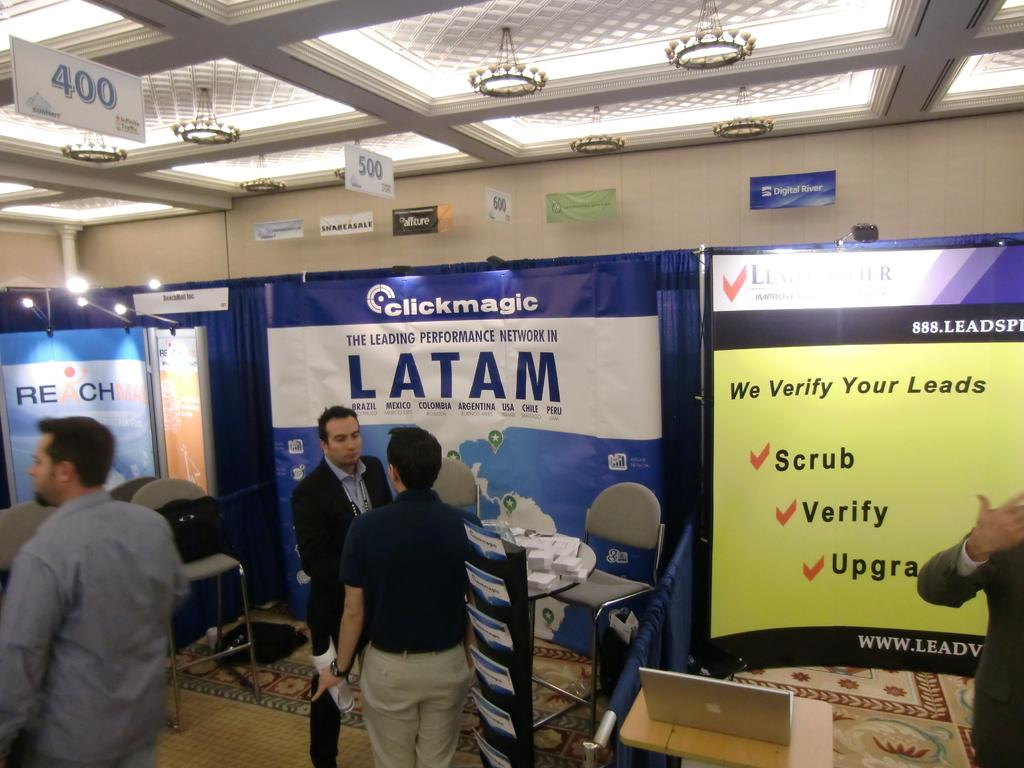What can be seen in the image involving people? There are people standing in the image. What type of furniture is present in the image? Chairs are present in the image. What electronic device can be seen on a table in the image? There is a laptop on a table in the image. What can be seen in the background of the image? Banners are visible in the background of the image. Where is the nest located in the image? There is no nest present in the image. What type of guide can be seen assisting the people in the image? There is no guide present in the image; the people are standing without assistance. 